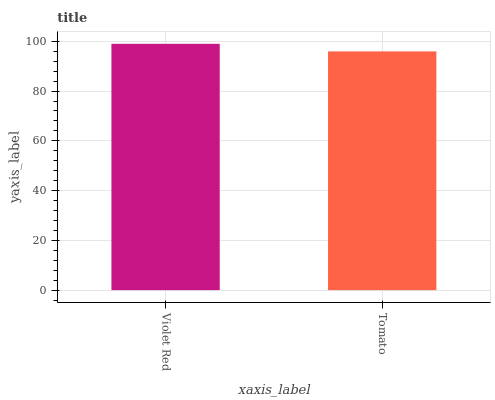Is Tomato the minimum?
Answer yes or no. Yes. Is Violet Red the maximum?
Answer yes or no. Yes. Is Tomato the maximum?
Answer yes or no. No. Is Violet Red greater than Tomato?
Answer yes or no. Yes. Is Tomato less than Violet Red?
Answer yes or no. Yes. Is Tomato greater than Violet Red?
Answer yes or no. No. Is Violet Red less than Tomato?
Answer yes or no. No. Is Violet Red the high median?
Answer yes or no. Yes. Is Tomato the low median?
Answer yes or no. Yes. Is Tomato the high median?
Answer yes or no. No. Is Violet Red the low median?
Answer yes or no. No. 